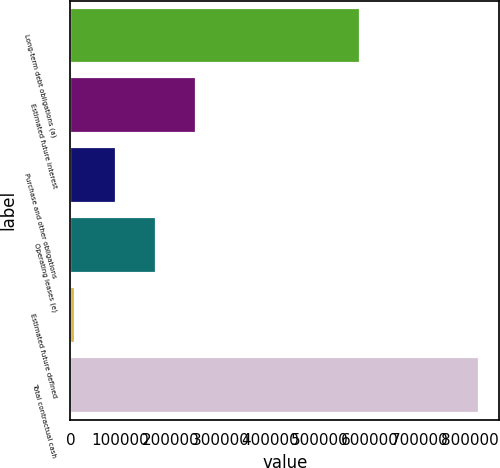<chart> <loc_0><loc_0><loc_500><loc_500><bar_chart><fcel>Long-term debt obligations (a)<fcel>Estimated future interest<fcel>Purchase and other obligations<fcel>Operating leases (e)<fcel>Estimated future defined<fcel>Total contractual cash<nl><fcel>579338<fcel>252185<fcel>90559.8<fcel>171373<fcel>9747<fcel>817875<nl></chart> 